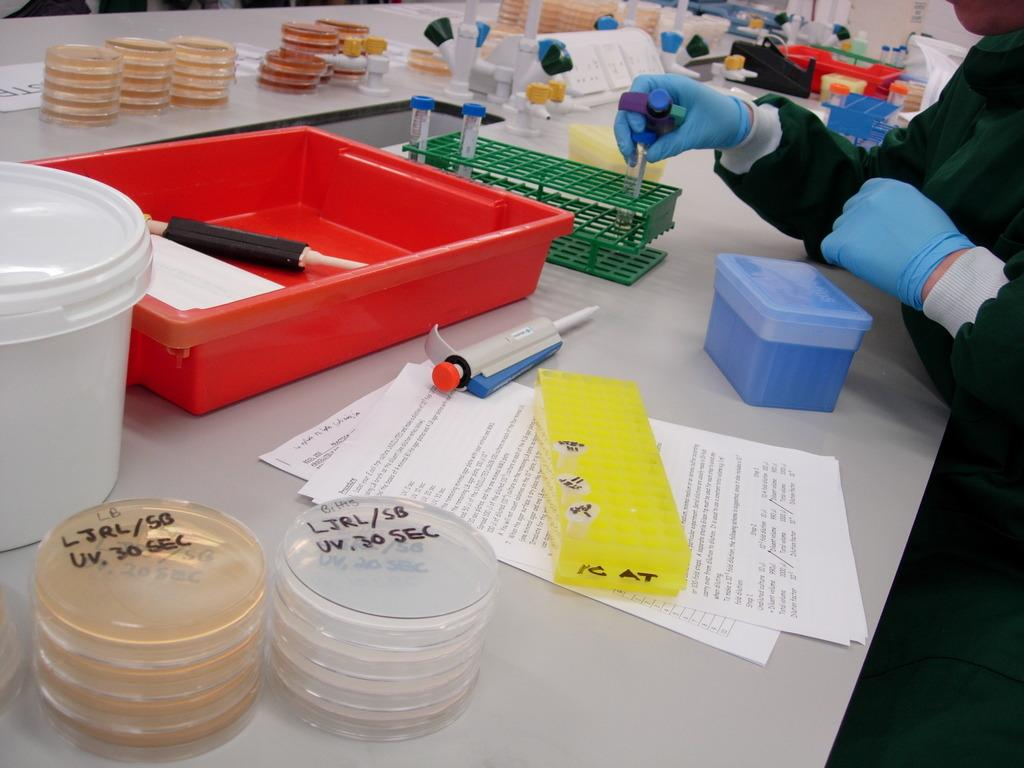What is the person in the image doing? The person is standing in the image and holding a tool. What is on the table in the image? The table contains papers, containers, tubes in a stand, tools, and other objects. Can you describe the tool the person is holding? The fact does not specify the type of tool the person is holding, so we cannot describe it. What type of competition is taking place in the image? There is no competition present in the image. What happens when the tubes in the stand burst in the image? There is no indication of any bursting tubes in the image. 